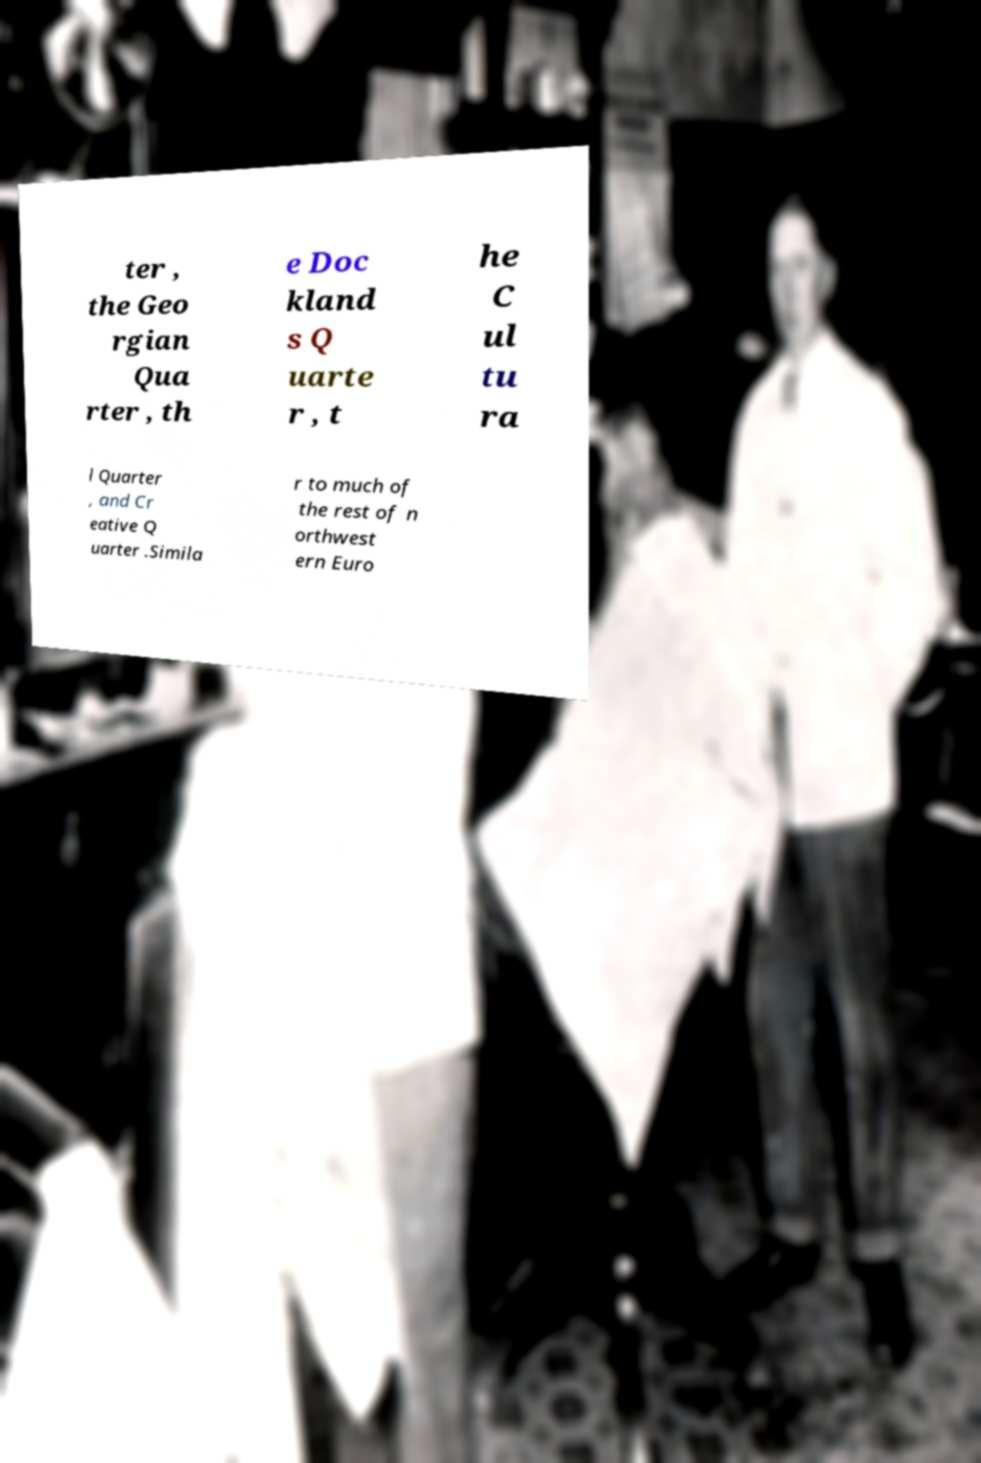There's text embedded in this image that I need extracted. Can you transcribe it verbatim? ter , the Geo rgian Qua rter , th e Doc kland s Q uarte r , t he C ul tu ra l Quarter , and Cr eative Q uarter .Simila r to much of the rest of n orthwest ern Euro 